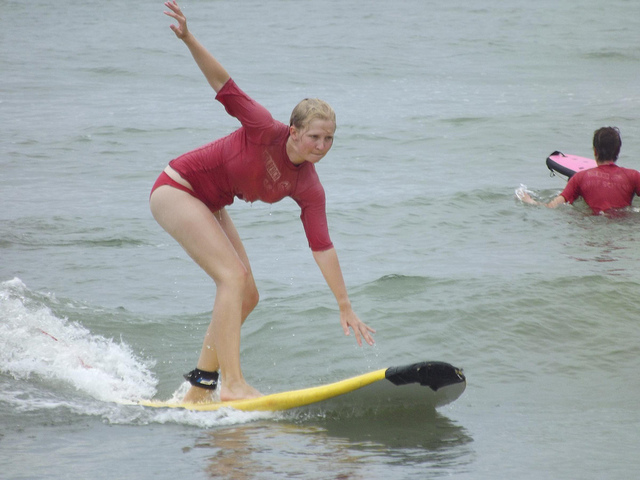<image>Is the women wearing a bikini? It is ambiguous whether the woman is wearing a bikini. She could be wearing a bikini or not. Is the women wearing a bikini? I am not sure if the woman is wearing a bikini. However, it can be seen a bikini bottom. 